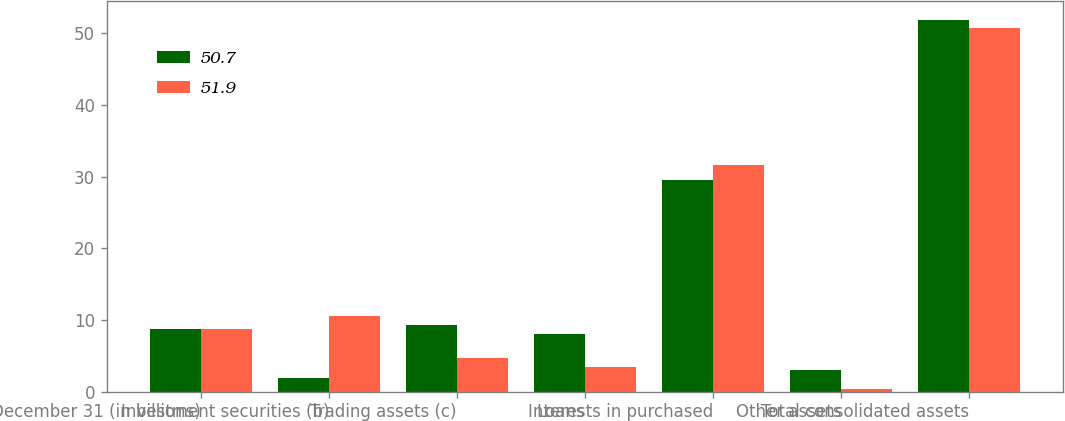<chart> <loc_0><loc_0><loc_500><loc_500><stacked_bar_chart><ecel><fcel>December 31 (in billions)<fcel>Investment securities (b)<fcel>Trading assets (c)<fcel>Loans<fcel>Interests in purchased<fcel>Other assets<fcel>Total consolidated assets<nl><fcel>50.7<fcel>8.7<fcel>1.9<fcel>9.3<fcel>8.1<fcel>29.6<fcel>3<fcel>51.9<nl><fcel>51.9<fcel>8.7<fcel>10.6<fcel>4.7<fcel>3.4<fcel>31.6<fcel>0.4<fcel>50.7<nl></chart> 